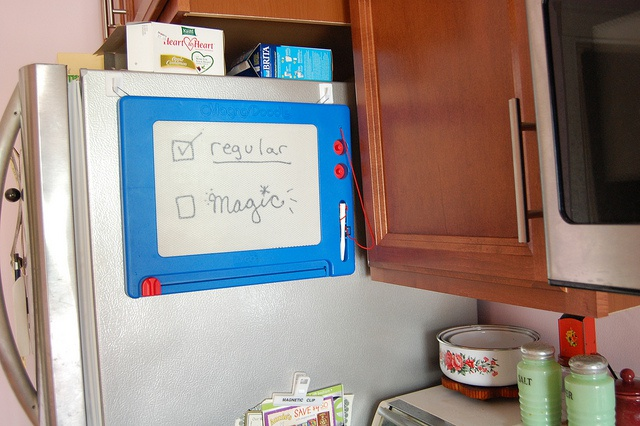Describe the objects in this image and their specific colors. I can see refrigerator in pink, lightgray, darkgray, gray, and tan tones, microwave in pink, black, darkgray, and gray tones, and bowl in pink, gray, darkgray, and lightgray tones in this image. 